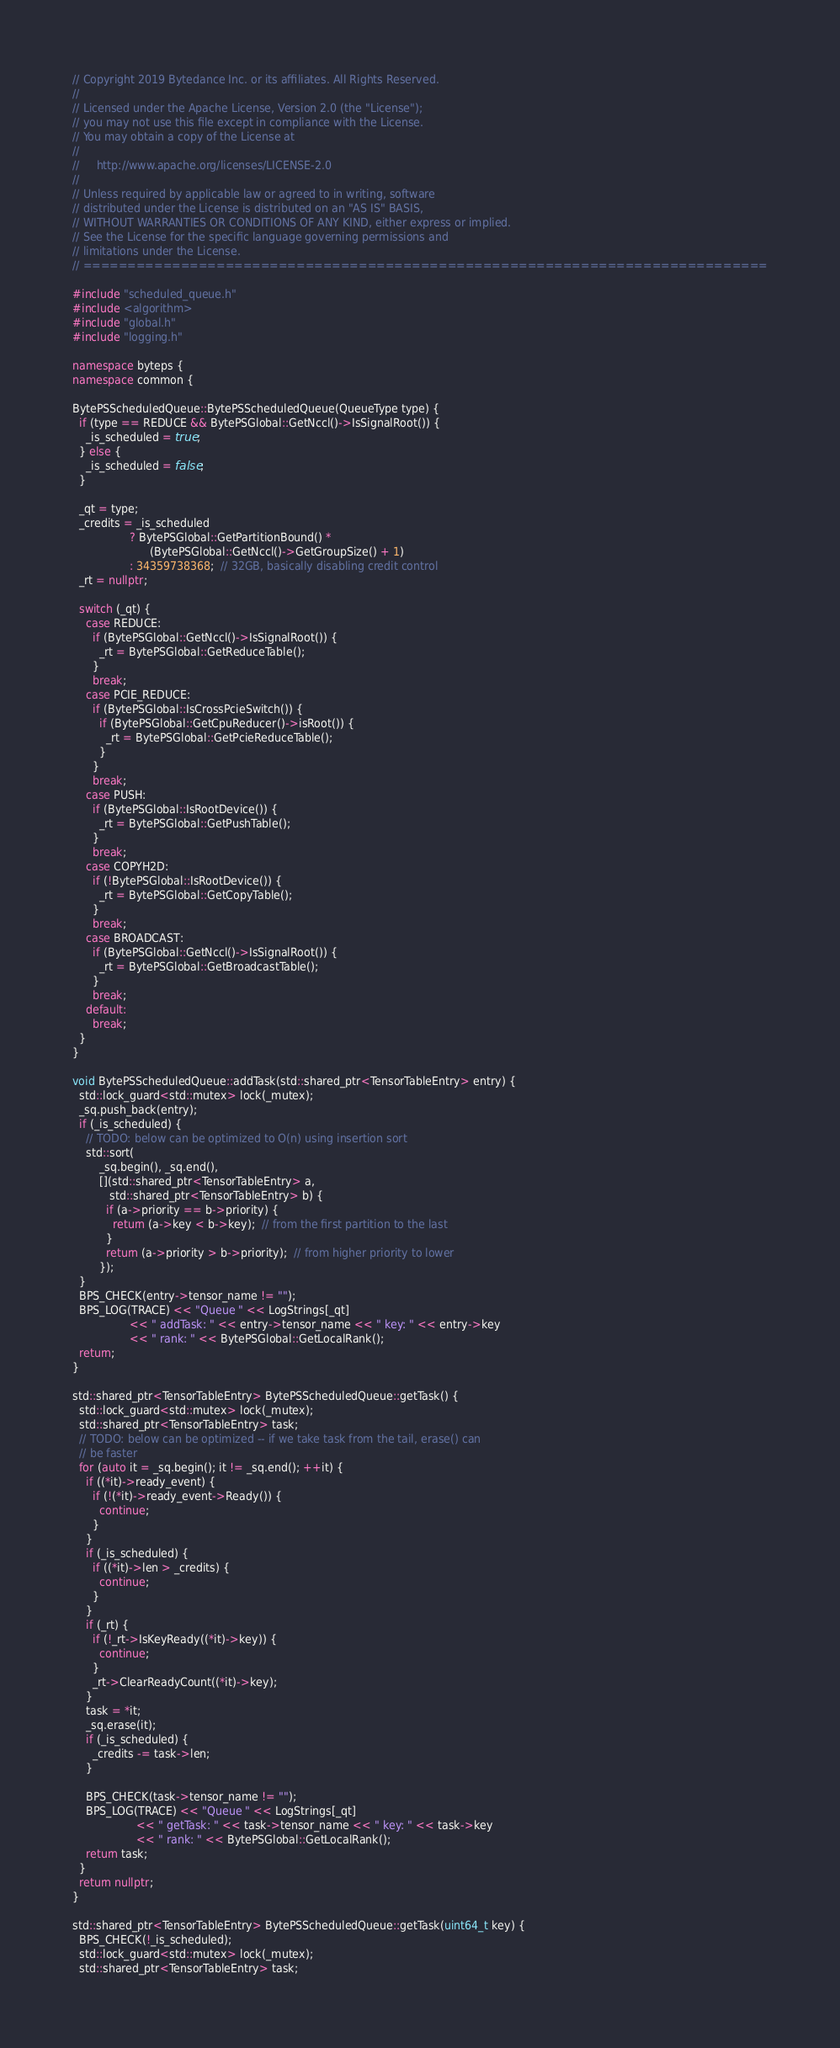Convert code to text. <code><loc_0><loc_0><loc_500><loc_500><_C++_>// Copyright 2019 Bytedance Inc. or its affiliates. All Rights Reserved.
//
// Licensed under the Apache License, Version 2.0 (the "License");
// you may not use this file except in compliance with the License.
// You may obtain a copy of the License at
//
//     http://www.apache.org/licenses/LICENSE-2.0
//
// Unless required by applicable law or agreed to in writing, software
// distributed under the License is distributed on an "AS IS" BASIS,
// WITHOUT WARRANTIES OR CONDITIONS OF ANY KIND, either express or implied.
// See the License for the specific language governing permissions and
// limitations under the License.
// =============================================================================

#include "scheduled_queue.h"
#include <algorithm>
#include "global.h"
#include "logging.h"

namespace byteps {
namespace common {

BytePSScheduledQueue::BytePSScheduledQueue(QueueType type) {
  if (type == REDUCE && BytePSGlobal::GetNccl()->IsSignalRoot()) {
    _is_scheduled = true;
  } else {
    _is_scheduled = false;
  }

  _qt = type;
  _credits = _is_scheduled
                 ? BytePSGlobal::GetPartitionBound() *
                       (BytePSGlobal::GetNccl()->GetGroupSize() + 1)
                 : 34359738368;  // 32GB, basically disabling credit control
  _rt = nullptr;

  switch (_qt) {
    case REDUCE:
      if (BytePSGlobal::GetNccl()->IsSignalRoot()) {
        _rt = BytePSGlobal::GetReduceTable();
      }
      break;
    case PCIE_REDUCE:
      if (BytePSGlobal::IsCrossPcieSwitch()) {
        if (BytePSGlobal::GetCpuReducer()->isRoot()) {
          _rt = BytePSGlobal::GetPcieReduceTable();
        }
      }
      break;
    case PUSH:
      if (BytePSGlobal::IsRootDevice()) {
        _rt = BytePSGlobal::GetPushTable();
      }
      break;
    case COPYH2D:
      if (!BytePSGlobal::IsRootDevice()) {
        _rt = BytePSGlobal::GetCopyTable();
      }
      break;
    case BROADCAST:
      if (BytePSGlobal::GetNccl()->IsSignalRoot()) {
        _rt = BytePSGlobal::GetBroadcastTable();
      }
      break;
    default:
      break;
  }
}

void BytePSScheduledQueue::addTask(std::shared_ptr<TensorTableEntry> entry) {
  std::lock_guard<std::mutex> lock(_mutex);
  _sq.push_back(entry);
  if (_is_scheduled) {
    // TODO: below can be optimized to O(n) using insertion sort
    std::sort(
        _sq.begin(), _sq.end(),
        [](std::shared_ptr<TensorTableEntry> a,
           std::shared_ptr<TensorTableEntry> b) {
          if (a->priority == b->priority) {
            return (a->key < b->key);  // from the first partition to the last
          }
          return (a->priority > b->priority);  // from higher priority to lower
        });
  }
  BPS_CHECK(entry->tensor_name != "");
  BPS_LOG(TRACE) << "Queue " << LogStrings[_qt]
                 << " addTask: " << entry->tensor_name << " key: " << entry->key
                 << " rank: " << BytePSGlobal::GetLocalRank();
  return;
}

std::shared_ptr<TensorTableEntry> BytePSScheduledQueue::getTask() {
  std::lock_guard<std::mutex> lock(_mutex);
  std::shared_ptr<TensorTableEntry> task;
  // TODO: below can be optimized -- if we take task from the tail, erase() can
  // be faster
  for (auto it = _sq.begin(); it != _sq.end(); ++it) {
    if ((*it)->ready_event) {
      if (!(*it)->ready_event->Ready()) {
        continue;
      }
    }
    if (_is_scheduled) {
      if ((*it)->len > _credits) {
        continue;
      }
    }
    if (_rt) {
      if (!_rt->IsKeyReady((*it)->key)) {
        continue;
      }
      _rt->ClearReadyCount((*it)->key);
    }
    task = *it;
    _sq.erase(it);
    if (_is_scheduled) {
      _credits -= task->len;
    }

    BPS_CHECK(task->tensor_name != "");
    BPS_LOG(TRACE) << "Queue " << LogStrings[_qt]
                   << " getTask: " << task->tensor_name << " key: " << task->key
                   << " rank: " << BytePSGlobal::GetLocalRank();
    return task;
  }
  return nullptr;
}

std::shared_ptr<TensorTableEntry> BytePSScheduledQueue::getTask(uint64_t key) {
  BPS_CHECK(!_is_scheduled);
  std::lock_guard<std::mutex> lock(_mutex);
  std::shared_ptr<TensorTableEntry> task;</code> 